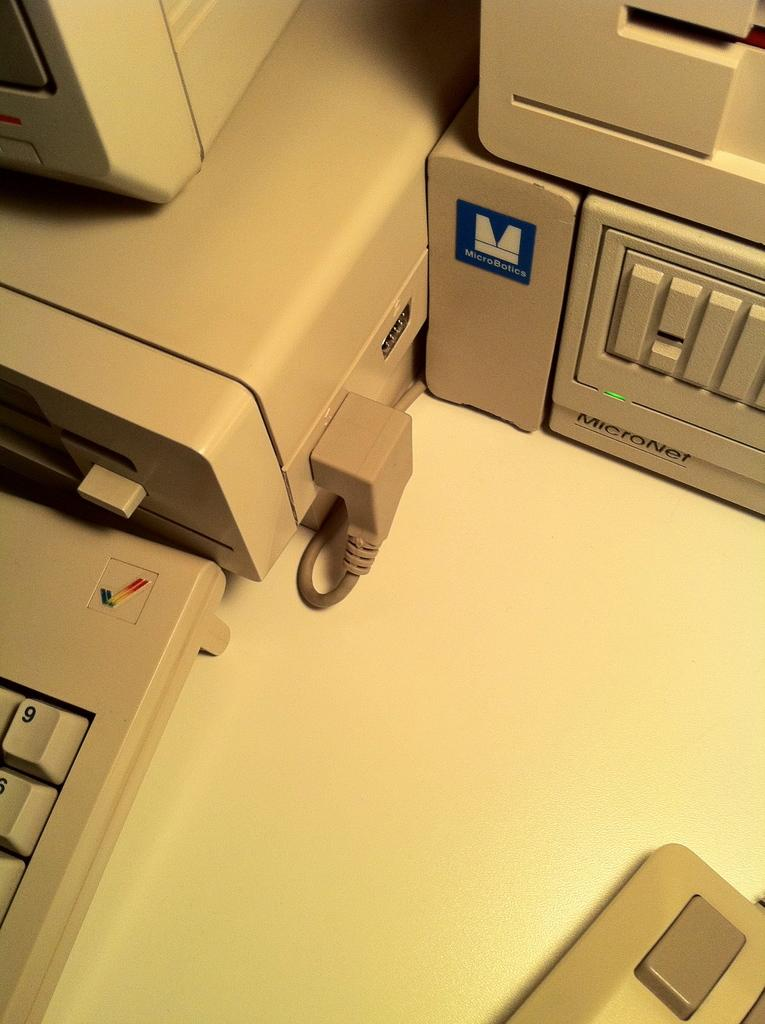<image>
Relay a brief, clear account of the picture shown. A desktop computer by MicroBotics and a separate keyboard all on a table. 